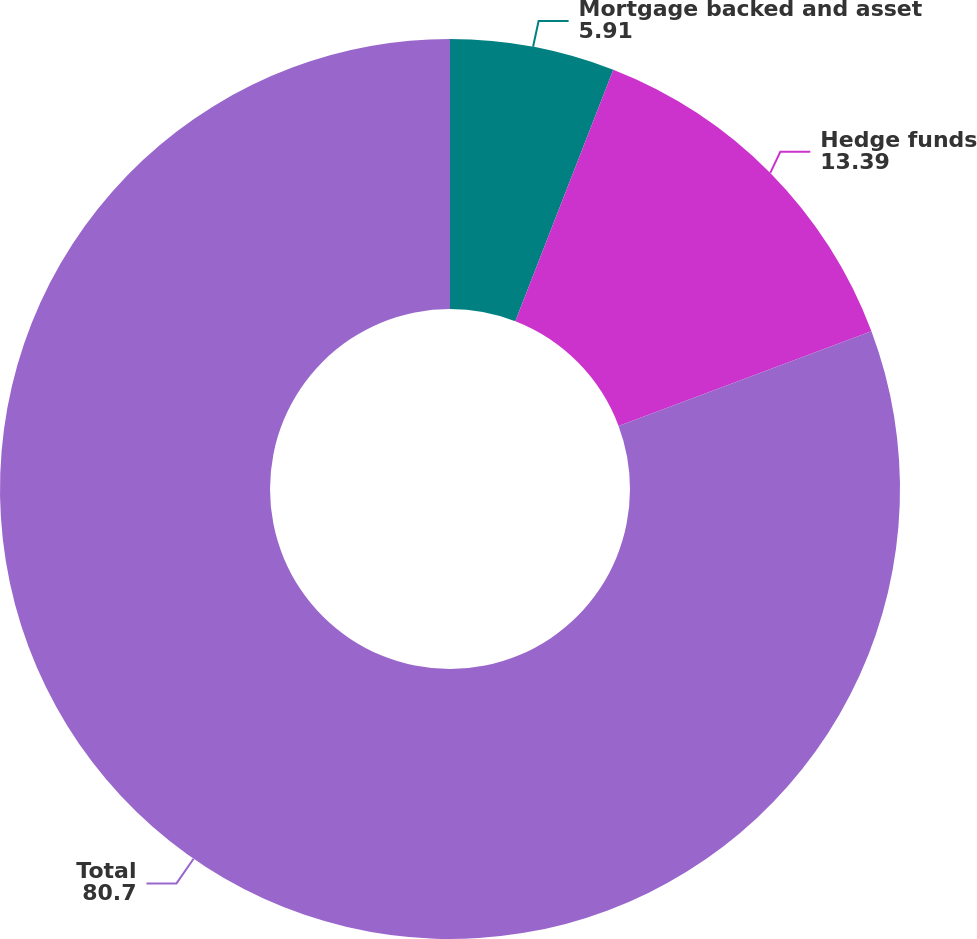<chart> <loc_0><loc_0><loc_500><loc_500><pie_chart><fcel>Mortgage backed and asset<fcel>Hedge funds<fcel>Total<nl><fcel>5.91%<fcel>13.39%<fcel>80.7%<nl></chart> 